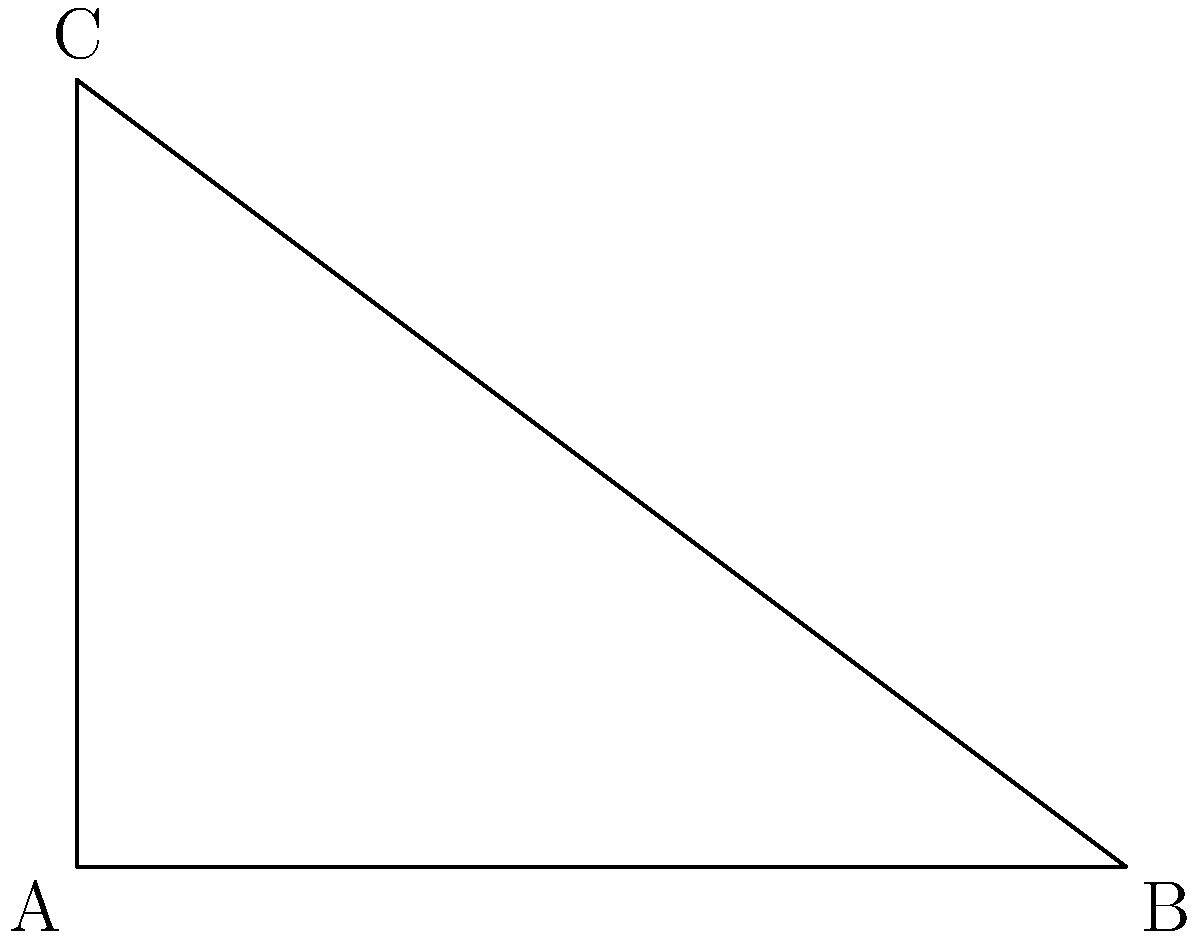An audio description states: "A right-angled triangle has a base of 4 units and a height of 3 units. What is the length of its hypotenuse?" To find the length of the hypotenuse, we can use the Pythagorean theorem:

1. The Pythagorean theorem states that in a right-angled triangle, $a^2 + b^2 = c^2$, where $c$ is the length of the hypotenuse and $a$ and $b$ are the lengths of the other two sides.

2. We know that the base is 4 units and the height is 3 units. Let's substitute these values:

   $a = 4$ (base)
   $b = 3$ (height)

3. Now, let's apply the Pythagorean theorem:

   $a^2 + b^2 = c^2$
   $4^2 + 3^2 = c^2$

4. Simplify:
   $16 + 9 = c^2$
   $25 = c^2$

5. To find $c$, we need to take the square root of both sides:

   $\sqrt{25} = c$

6. Simplify:
   $5 = c$

Therefore, the length of the hypotenuse is 5 units.
Answer: 5 units 